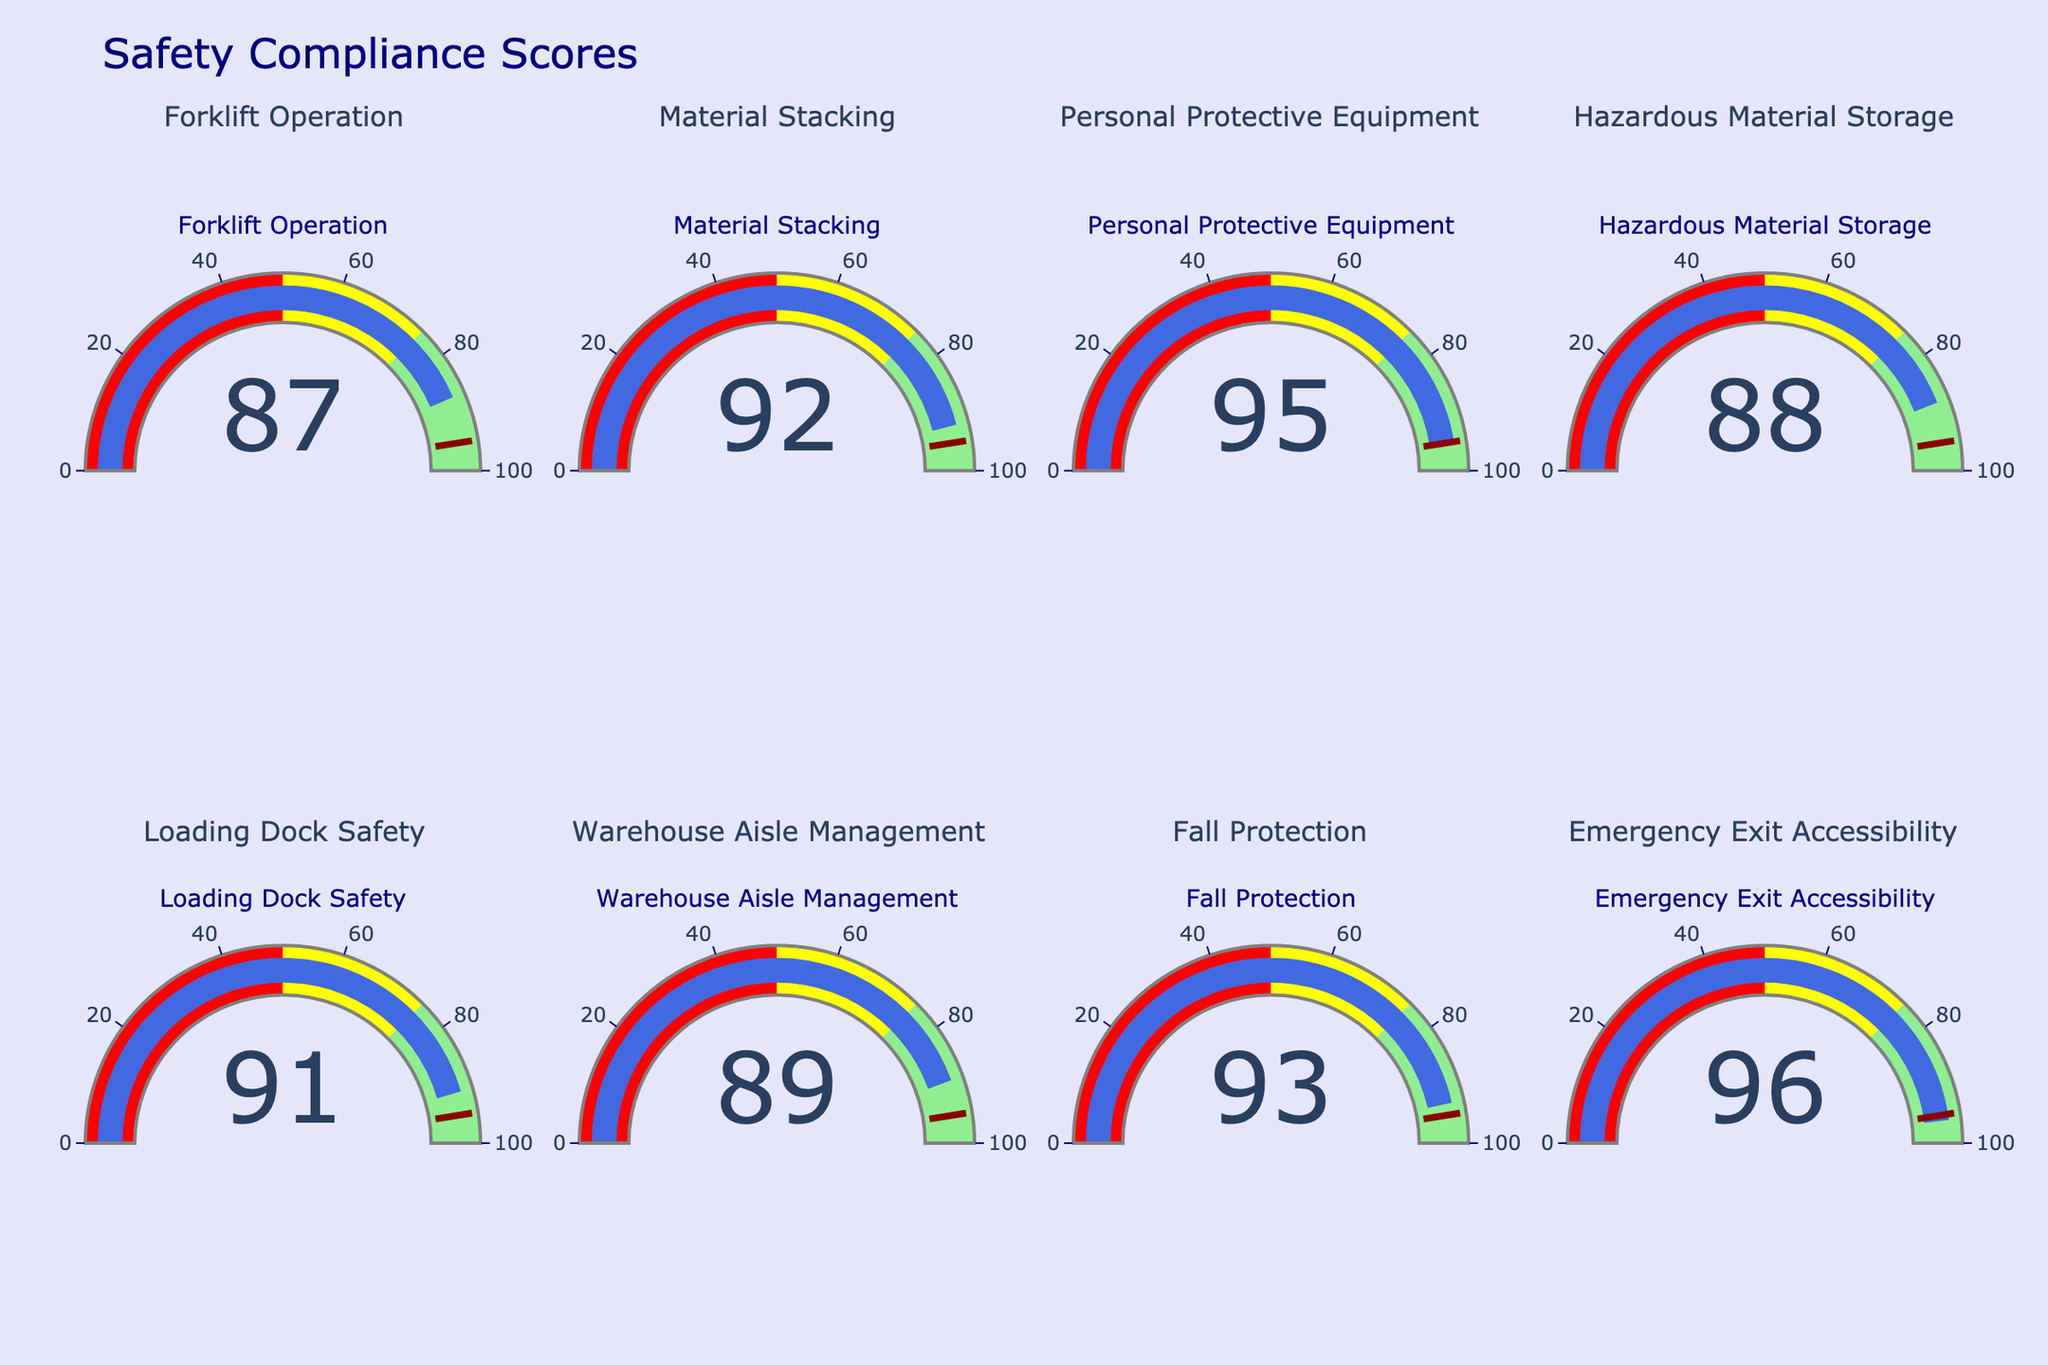What is the highest compliance score displayed on the gauges? The highest compliance score can be found by comparing the values on all gauges. Emergency Exit Accessibility shows a compliance score of 96, which is the highest among all the measures.
Answer: 96 Which safety measure has the lowest compliance score? To find the safety measure with the lowest compliance score, we need to look at all the gauges. Forklift Operation has the lowest compliance score of 87.
Answer: Forklift Operation How many safety measures have compliance scores above 90? By counting the gauges with compliance scores above 90, we get Material Stacking (92), Personal Protective Equipment (95), Loading Dock Safety (91), Fall Protection (93), and Emergency Exit Accessibility (96). Thus, there are five measures.
Answer: 5 What is the average compliance score across all safety measures? To calculate the average, sum all the compliance scores and divide by the number of measures: (87 + 92 + 95 + 88 + 91 + 89 + 93 + 96) / 8 = 731 / 8 = 91.375.
Answer: 91.375 Which safety measure is closest to the threshold of 95 set on the gauges? Looking at the threshold lines on the gauges, compare the scores close to 95. Personal Protective Equipment has a score of 95, which is the exact threshold. Hazardous Material Storage with a score of 88 is closest but still below the threshold.
Answer: Personal Protective Equipment How many safety measures fall in the 'light green' range (75-100)? The 'light green' range is from 75 to 100. All displayed measures (87, 92, 95, 88, 91, 89, 93, 96) fall within this range. Thus, all eight safety measures are in the 'light green' range.
Answer: 8 Which two safety measures have exactly the same compliance score? By examining all the gauges, no two measures have exactly the same compliance score. Each score is unique.
Answer: None Is there a safety measure with a compliance score less than 90? If so, which one? From the displayed gauges, Forklift Operation (87) and Hazardous Material Storage (88) have compliance scores less than 90.
Answer: Forklift Operation and Hazardous Material Storage What is the range of the compliance scores displayed on the figure? The range is calculated by subtracting the smallest value from the largest value on the gauges. The smallest score is 87 (Forklift Operation) and the largest is 96 (Emergency Exit Accessibility), so the range is 96 - 87 = 9.
Answer: 9 